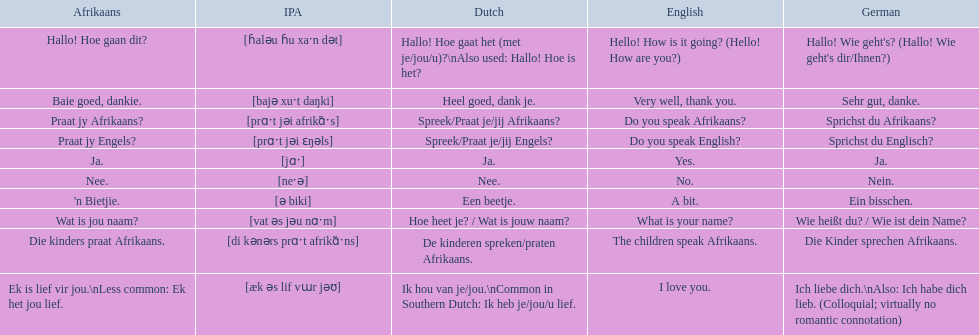What are the afrikaans expressions? Hallo! Hoe gaan dit?, Baie goed, dankie., Praat jy Afrikaans?, Praat jy Engels?, Ja., Nee., 'n Bietjie., Wat is jou naam?, Die kinders praat Afrikaans., Ek is lief vir jou.\nLess common: Ek het jou lief. For "die kinders praat afrikaans," what are the possible translations? De kinderen spreken/praten Afrikaans., The children speak Afrikaans., Die Kinder sprechen Afrikaans. Which of them is the german version? Die Kinder sprechen Afrikaans. 